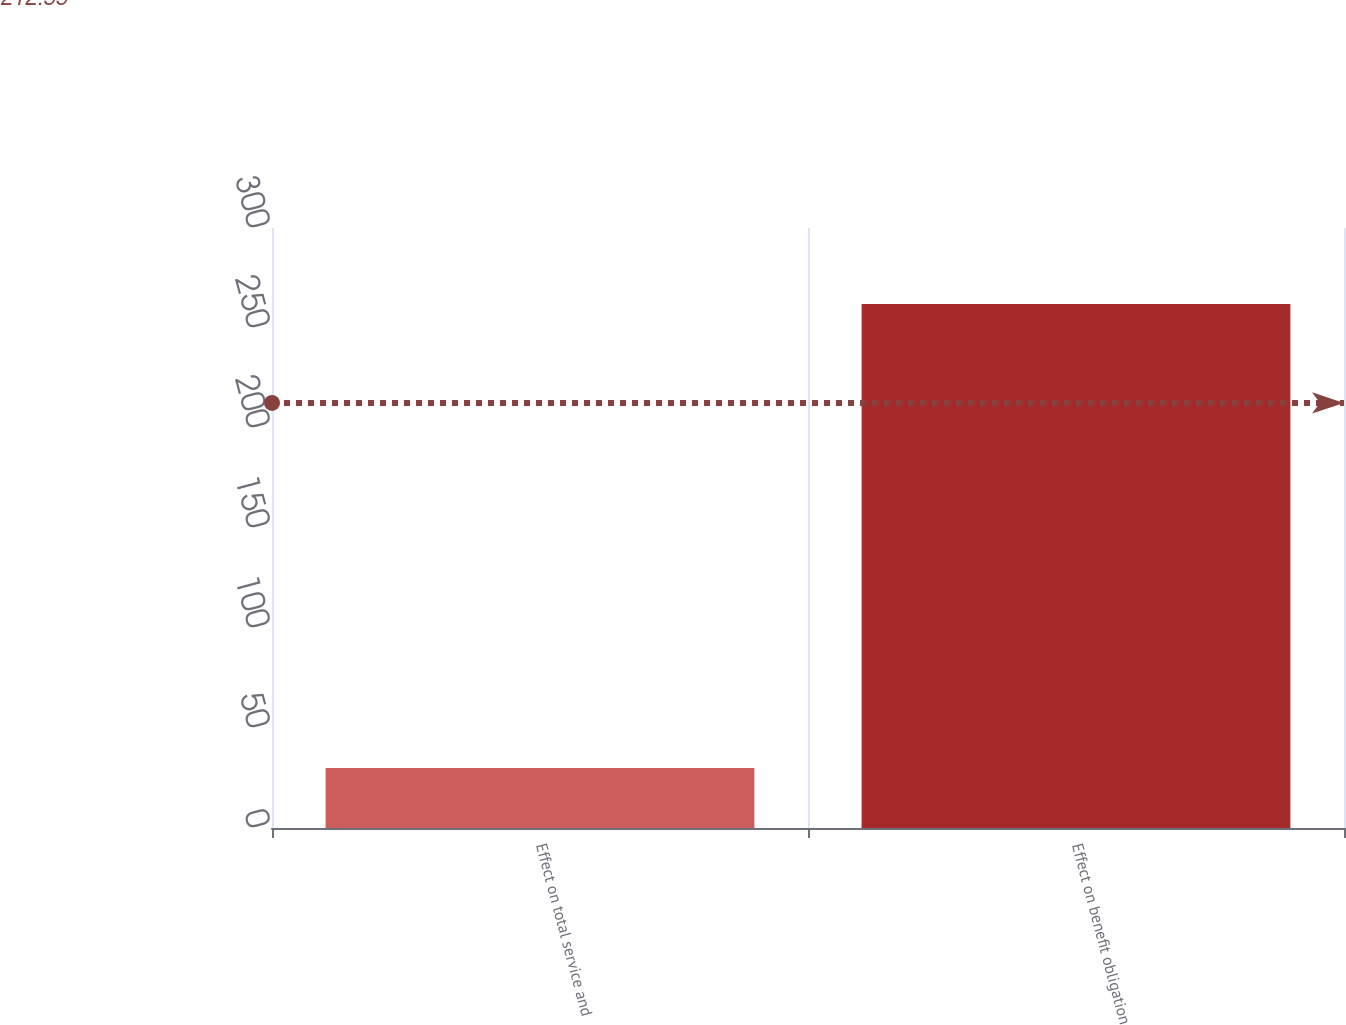Convert chart to OTSL. <chart><loc_0><loc_0><loc_500><loc_500><bar_chart><fcel>Effect on total service and<fcel>Effect on benefit obligation<nl><fcel>30<fcel>262<nl></chart> 